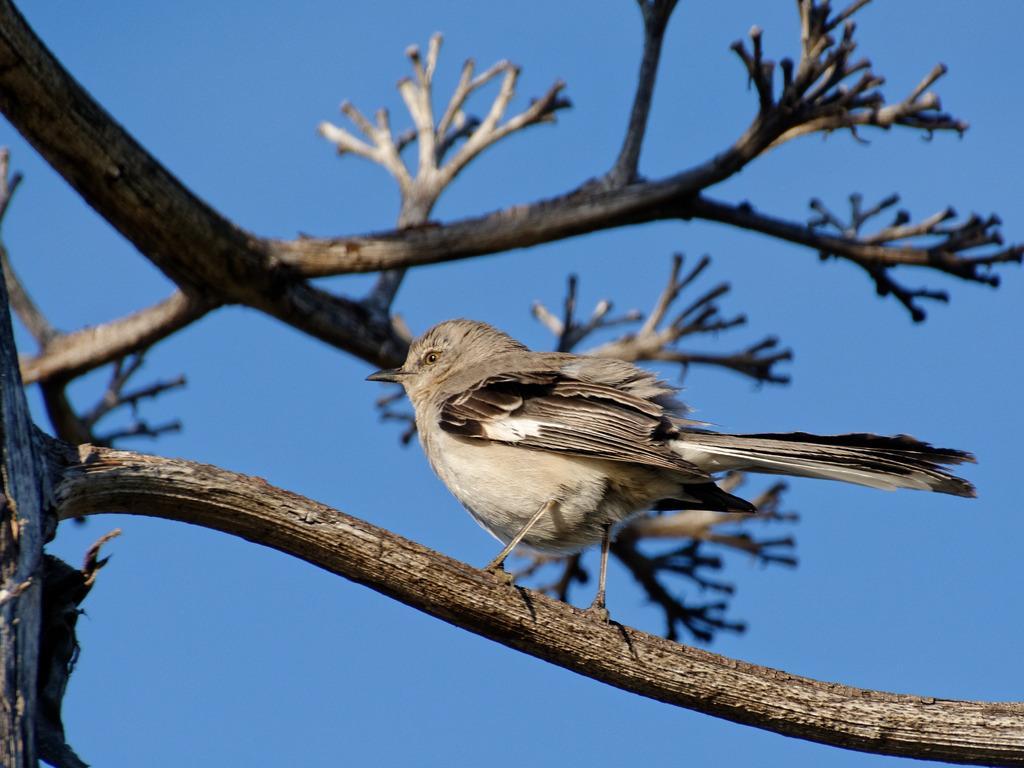Describe this image in one or two sentences. In the picture we can see a dried tree stem on it, we can see a bird which is some part cream in color and some part gray in color and behind the tree we can see a sky which is blue in color. 